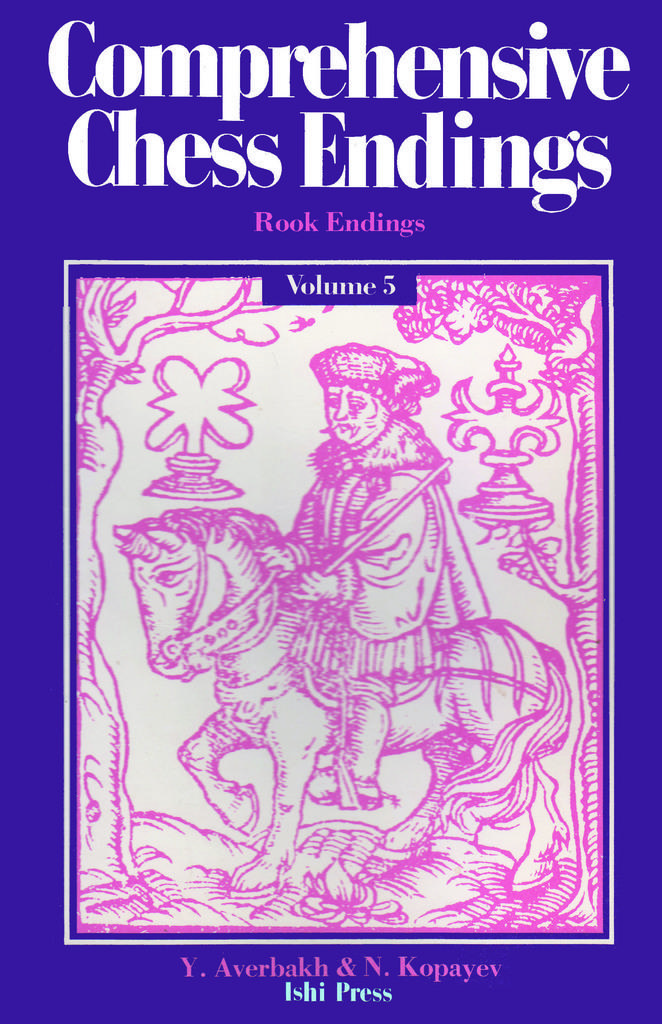Who volume is the book?
Make the answer very short. 5. 